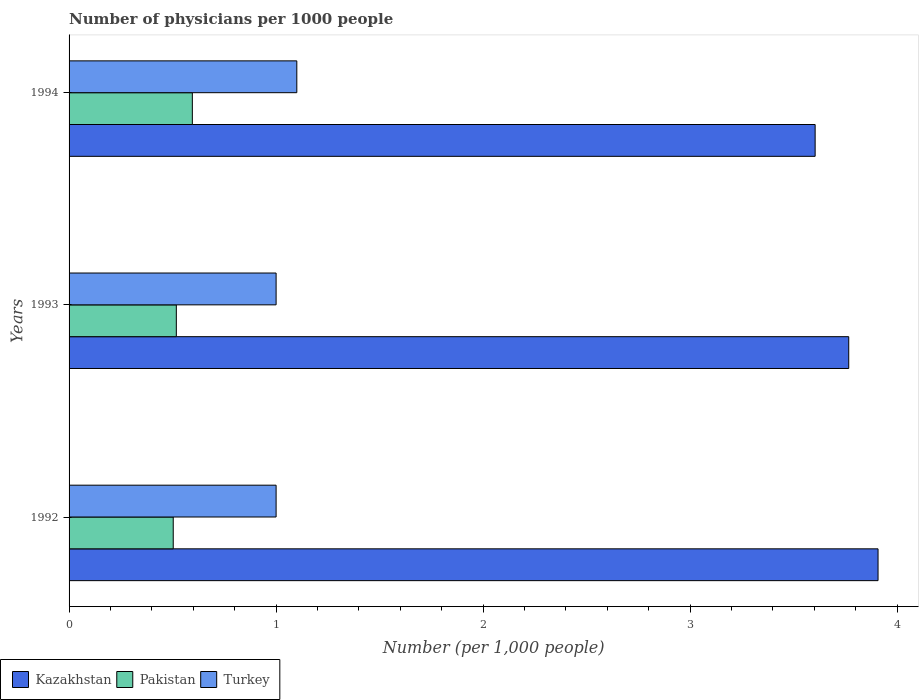Are the number of bars per tick equal to the number of legend labels?
Offer a very short reply. Yes. How many bars are there on the 2nd tick from the top?
Provide a short and direct response. 3. How many bars are there on the 2nd tick from the bottom?
Provide a short and direct response. 3. In how many cases, is the number of bars for a given year not equal to the number of legend labels?
Keep it short and to the point. 0. Across all years, what is the maximum number of physicians in Pakistan?
Offer a terse response. 0.6. Across all years, what is the minimum number of physicians in Pakistan?
Provide a short and direct response. 0.5. What is the difference between the number of physicians in Pakistan in 1993 and that in 1994?
Keep it short and to the point. -0.08. What is the difference between the number of physicians in Pakistan in 1994 and the number of physicians in Turkey in 1992?
Ensure brevity in your answer.  -0.4. What is the average number of physicians in Pakistan per year?
Provide a short and direct response. 0.54. In the year 1994, what is the difference between the number of physicians in Turkey and number of physicians in Pakistan?
Provide a short and direct response. 0.5. Is the number of physicians in Turkey in 1992 less than that in 1994?
Give a very brief answer. Yes. Is the difference between the number of physicians in Turkey in 1992 and 1993 greater than the difference between the number of physicians in Pakistan in 1992 and 1993?
Your response must be concise. Yes. What is the difference between the highest and the second highest number of physicians in Kazakhstan?
Keep it short and to the point. 0.14. What is the difference between the highest and the lowest number of physicians in Turkey?
Provide a short and direct response. 0.1. What does the 2nd bar from the top in 1993 represents?
Your response must be concise. Pakistan. How many bars are there?
Provide a succinct answer. 9. What is the difference between two consecutive major ticks on the X-axis?
Your answer should be compact. 1. Are the values on the major ticks of X-axis written in scientific E-notation?
Your answer should be compact. No. Does the graph contain grids?
Your answer should be compact. No. Where does the legend appear in the graph?
Offer a very short reply. Bottom left. How many legend labels are there?
Your answer should be very brief. 3. What is the title of the graph?
Offer a very short reply. Number of physicians per 1000 people. Does "Syrian Arab Republic" appear as one of the legend labels in the graph?
Provide a short and direct response. No. What is the label or title of the X-axis?
Your answer should be very brief. Number (per 1,0 people). What is the Number (per 1,000 people) in Kazakhstan in 1992?
Ensure brevity in your answer.  3.91. What is the Number (per 1,000 people) in Pakistan in 1992?
Give a very brief answer. 0.5. What is the Number (per 1,000 people) in Turkey in 1992?
Offer a very short reply. 1. What is the Number (per 1,000 people) of Kazakhstan in 1993?
Offer a very short reply. 3.77. What is the Number (per 1,000 people) of Pakistan in 1993?
Make the answer very short. 0.52. What is the Number (per 1,000 people) in Kazakhstan in 1994?
Keep it short and to the point. 3.6. What is the Number (per 1,000 people) in Pakistan in 1994?
Your answer should be compact. 0.6. What is the Number (per 1,000 people) of Turkey in 1994?
Your response must be concise. 1.1. Across all years, what is the maximum Number (per 1,000 people) of Kazakhstan?
Your response must be concise. 3.91. Across all years, what is the maximum Number (per 1,000 people) of Pakistan?
Your answer should be very brief. 0.6. Across all years, what is the minimum Number (per 1,000 people) of Kazakhstan?
Your answer should be compact. 3.6. Across all years, what is the minimum Number (per 1,000 people) in Pakistan?
Give a very brief answer. 0.5. What is the total Number (per 1,000 people) in Kazakhstan in the graph?
Provide a succinct answer. 11.28. What is the total Number (per 1,000 people) of Pakistan in the graph?
Your answer should be compact. 1.62. What is the total Number (per 1,000 people) in Turkey in the graph?
Your answer should be compact. 3.1. What is the difference between the Number (per 1,000 people) of Kazakhstan in 1992 and that in 1993?
Ensure brevity in your answer.  0.14. What is the difference between the Number (per 1,000 people) in Pakistan in 1992 and that in 1993?
Your response must be concise. -0.01. What is the difference between the Number (per 1,000 people) of Turkey in 1992 and that in 1993?
Your answer should be very brief. 0. What is the difference between the Number (per 1,000 people) in Kazakhstan in 1992 and that in 1994?
Give a very brief answer. 0.3. What is the difference between the Number (per 1,000 people) in Pakistan in 1992 and that in 1994?
Offer a very short reply. -0.09. What is the difference between the Number (per 1,000 people) in Turkey in 1992 and that in 1994?
Offer a very short reply. -0.1. What is the difference between the Number (per 1,000 people) in Kazakhstan in 1993 and that in 1994?
Your response must be concise. 0.16. What is the difference between the Number (per 1,000 people) of Pakistan in 1993 and that in 1994?
Keep it short and to the point. -0.08. What is the difference between the Number (per 1,000 people) in Turkey in 1993 and that in 1994?
Give a very brief answer. -0.1. What is the difference between the Number (per 1,000 people) in Kazakhstan in 1992 and the Number (per 1,000 people) in Pakistan in 1993?
Provide a short and direct response. 3.39. What is the difference between the Number (per 1,000 people) of Kazakhstan in 1992 and the Number (per 1,000 people) of Turkey in 1993?
Provide a succinct answer. 2.91. What is the difference between the Number (per 1,000 people) in Pakistan in 1992 and the Number (per 1,000 people) in Turkey in 1993?
Offer a terse response. -0.5. What is the difference between the Number (per 1,000 people) of Kazakhstan in 1992 and the Number (per 1,000 people) of Pakistan in 1994?
Provide a short and direct response. 3.31. What is the difference between the Number (per 1,000 people) in Kazakhstan in 1992 and the Number (per 1,000 people) in Turkey in 1994?
Provide a succinct answer. 2.81. What is the difference between the Number (per 1,000 people) of Pakistan in 1992 and the Number (per 1,000 people) of Turkey in 1994?
Provide a short and direct response. -0.6. What is the difference between the Number (per 1,000 people) of Kazakhstan in 1993 and the Number (per 1,000 people) of Pakistan in 1994?
Make the answer very short. 3.17. What is the difference between the Number (per 1,000 people) of Kazakhstan in 1993 and the Number (per 1,000 people) of Turkey in 1994?
Ensure brevity in your answer.  2.67. What is the difference between the Number (per 1,000 people) of Pakistan in 1993 and the Number (per 1,000 people) of Turkey in 1994?
Keep it short and to the point. -0.58. What is the average Number (per 1,000 people) of Kazakhstan per year?
Provide a succinct answer. 3.76. What is the average Number (per 1,000 people) of Pakistan per year?
Your response must be concise. 0.54. What is the average Number (per 1,000 people) of Turkey per year?
Your answer should be very brief. 1.03. In the year 1992, what is the difference between the Number (per 1,000 people) of Kazakhstan and Number (per 1,000 people) of Pakistan?
Your answer should be compact. 3.4. In the year 1992, what is the difference between the Number (per 1,000 people) in Kazakhstan and Number (per 1,000 people) in Turkey?
Make the answer very short. 2.91. In the year 1992, what is the difference between the Number (per 1,000 people) of Pakistan and Number (per 1,000 people) of Turkey?
Keep it short and to the point. -0.5. In the year 1993, what is the difference between the Number (per 1,000 people) of Kazakhstan and Number (per 1,000 people) of Pakistan?
Make the answer very short. 3.25. In the year 1993, what is the difference between the Number (per 1,000 people) in Kazakhstan and Number (per 1,000 people) in Turkey?
Provide a short and direct response. 2.77. In the year 1993, what is the difference between the Number (per 1,000 people) in Pakistan and Number (per 1,000 people) in Turkey?
Your answer should be compact. -0.48. In the year 1994, what is the difference between the Number (per 1,000 people) in Kazakhstan and Number (per 1,000 people) in Pakistan?
Offer a very short reply. 3.01. In the year 1994, what is the difference between the Number (per 1,000 people) of Kazakhstan and Number (per 1,000 people) of Turkey?
Make the answer very short. 2.5. In the year 1994, what is the difference between the Number (per 1,000 people) of Pakistan and Number (per 1,000 people) of Turkey?
Your answer should be very brief. -0.5. What is the ratio of the Number (per 1,000 people) of Kazakhstan in 1992 to that in 1993?
Give a very brief answer. 1.04. What is the ratio of the Number (per 1,000 people) of Kazakhstan in 1992 to that in 1994?
Keep it short and to the point. 1.08. What is the ratio of the Number (per 1,000 people) of Pakistan in 1992 to that in 1994?
Your response must be concise. 0.84. What is the ratio of the Number (per 1,000 people) of Kazakhstan in 1993 to that in 1994?
Your response must be concise. 1.04. What is the ratio of the Number (per 1,000 people) in Pakistan in 1993 to that in 1994?
Make the answer very short. 0.87. What is the ratio of the Number (per 1,000 people) of Turkey in 1993 to that in 1994?
Your response must be concise. 0.91. What is the difference between the highest and the second highest Number (per 1,000 people) of Kazakhstan?
Give a very brief answer. 0.14. What is the difference between the highest and the second highest Number (per 1,000 people) of Pakistan?
Offer a terse response. 0.08. What is the difference between the highest and the lowest Number (per 1,000 people) of Kazakhstan?
Offer a very short reply. 0.3. What is the difference between the highest and the lowest Number (per 1,000 people) in Pakistan?
Offer a very short reply. 0.09. 